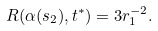Convert formula to latex. <formula><loc_0><loc_0><loc_500><loc_500>R ( \alpha ( s _ { 2 } ) , t ^ { * } ) = 3 r _ { 1 } ^ { - 2 } .</formula> 